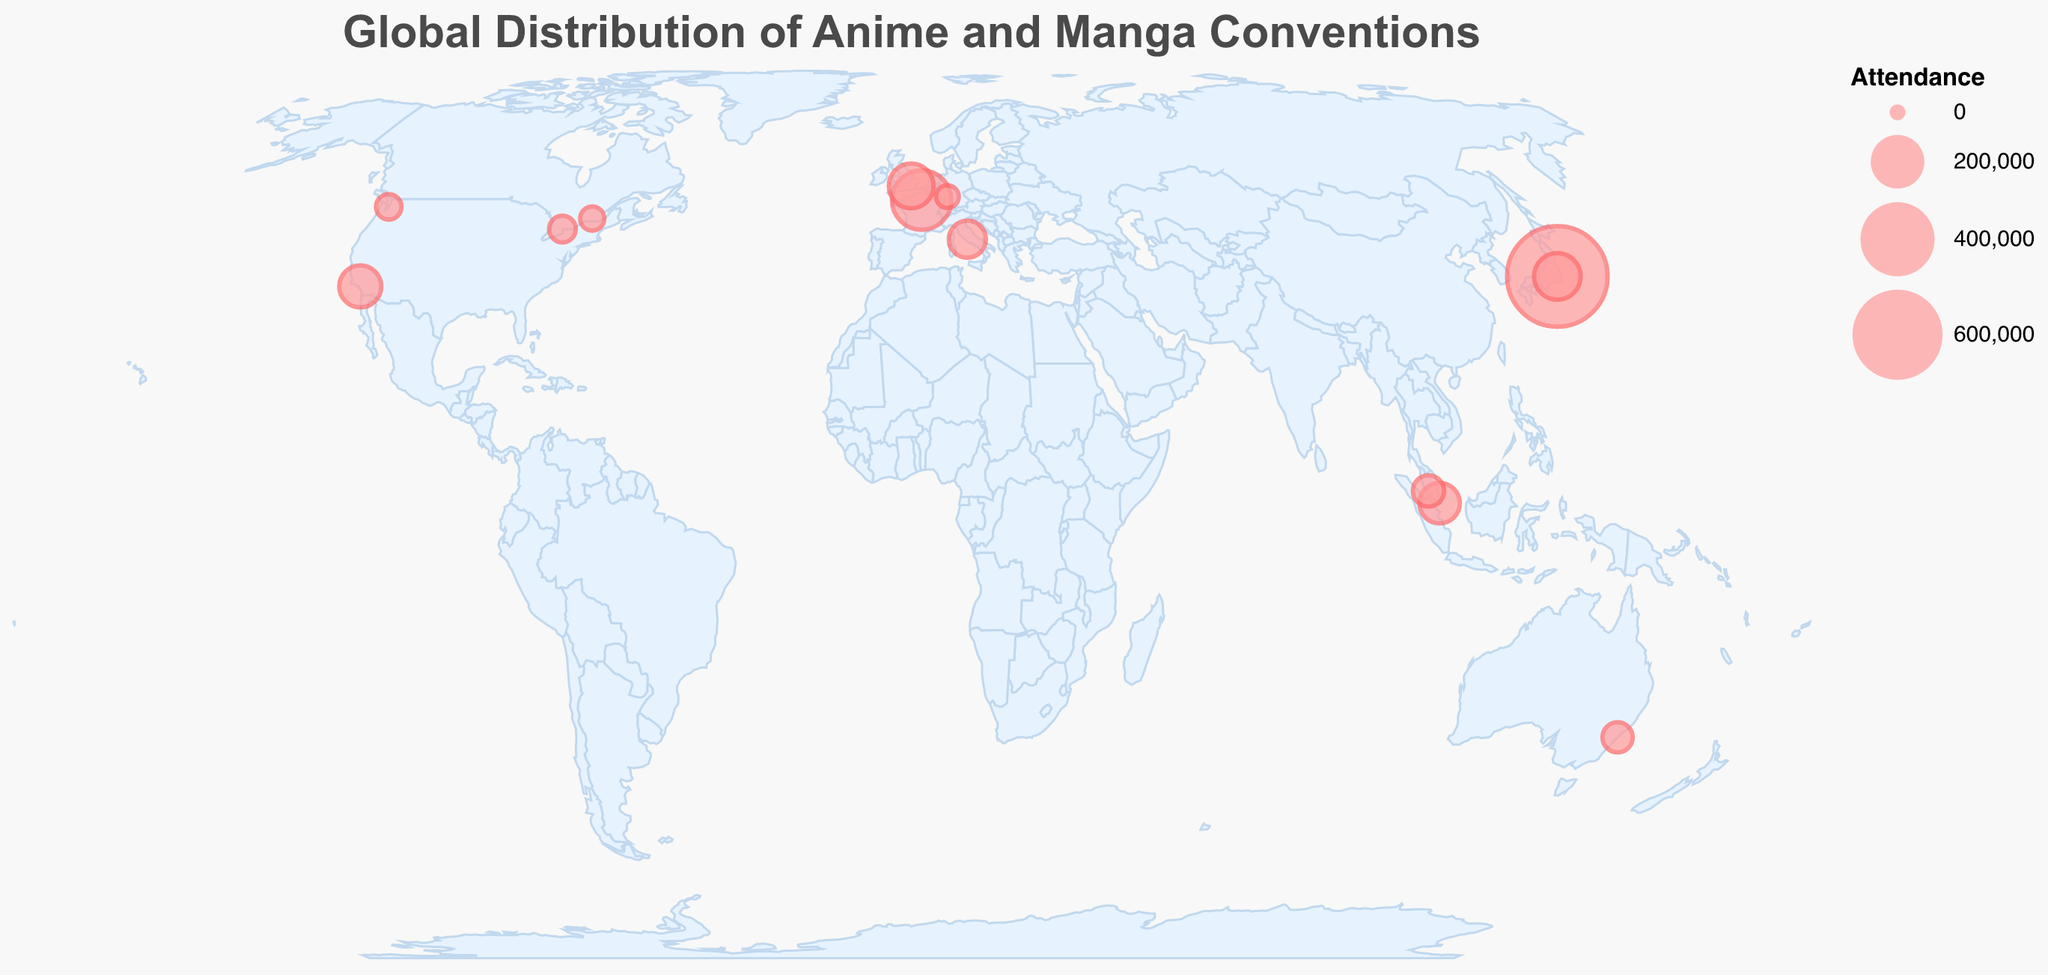Which city hosts the convention with the highest attendance? Comiket in Tokyo, Japan has the highest attendance with 750,000 people.
Answer: Comiket in Tokyo What is the title of the figure? The title of the figure is displayed at the top and reads "Global Distribution of Anime and Manga Conventions".
Answer: Global Distribution of Anime and Manga Conventions How many conventions are there in the USA according to the figure? The USA conventions are "Anime Expo" in Los Angeles and "Sakura-Con" in Seattle, which totals to two conventions.
Answer: 2 Which convention has the smallest attendance figure? AnimagiC in Mannheim, Germany shows the smallest attendance with 20,000 people.
Answer: AnimagiC Are there more conventions with attendance over 100,000 in Europe or Asia? There are two conventions with attendance over 100,000 in Europe (Japan Expo in Paris and MCM London Comic Con) and two in Asia (Comiket in Tokyo and AnimeJapan in Tokyo).
Answer: Tie (2 each) Which convention is held farthest south in terms of latitude? Supanova in Sydney, Australia has the farthest south latitude of -33.8688.
Answer: Supanova in Sydney What is the total attendance for all conventions held in Japan? Comiket and AnimeJapan are held in Japan with attendance of 750,000 and 146,000 respectively. Summing these gives a total of 750,000 + 146,000 = 896,000.
Answer: 896,000 Which convention located in Southeast Asia has the highest attendance? Anime Festival Asia in Singapore has the highest attendance among Southeast Asian conventions, with 105,000 people.
Answer: Anime Festival Asia If you sum the attendance of all conventions held in North America, what is the total? Conventions in North America include Anime Expo, Otakuthon, Sakura-Con, and Anime North with attendances of 115,000, 25,000, 30,000, and 35,000 respectively. The total is 115,000 + 25,000 + 30,000 + 35,000 = 205,000.
Answer: 205,000 How does the attendance of MCM London Comic Con compare to Anime Expo? MCM London Comic Con has an attendance of 133,000, which is higher than Anime Expo's 115,000. The difference is 133,000 - 115,000 = 18,000.
Answer: 18,000 more 